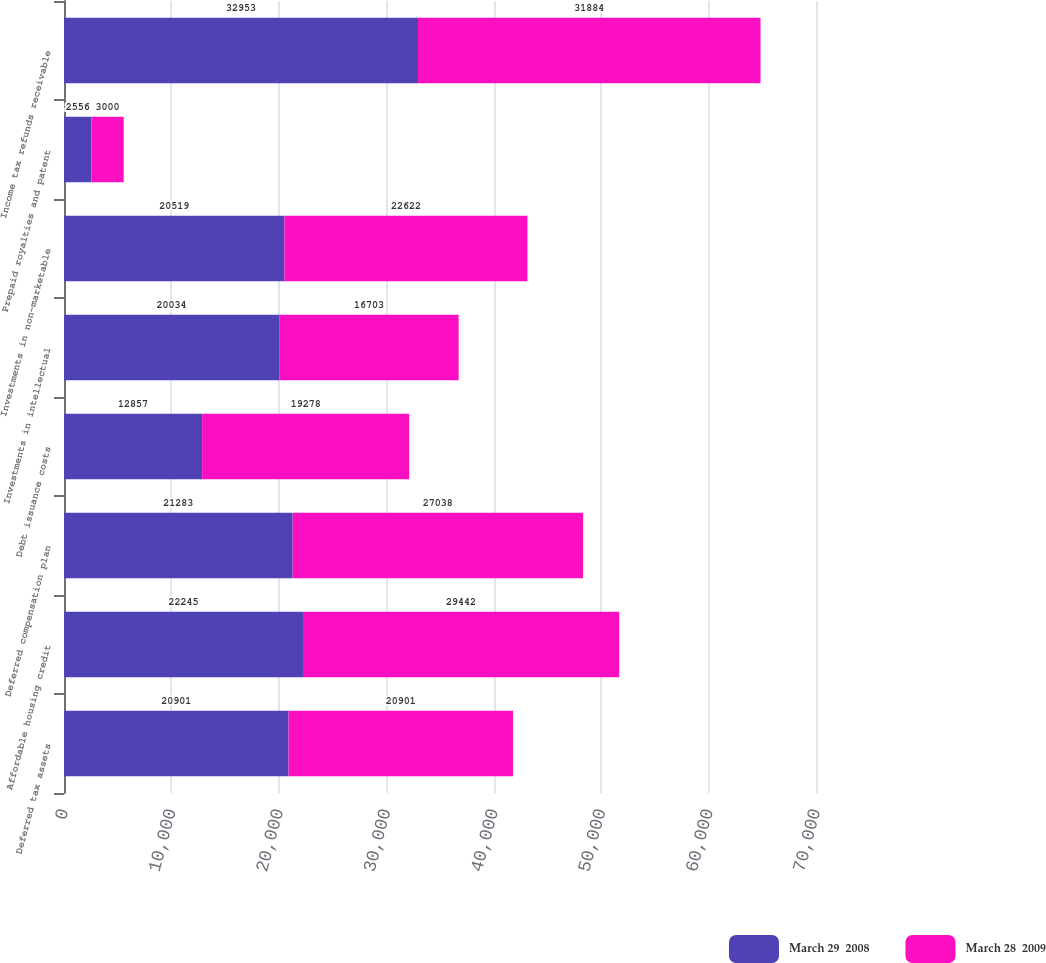Convert chart. <chart><loc_0><loc_0><loc_500><loc_500><stacked_bar_chart><ecel><fcel>Deferred tax assets<fcel>Affordable housing credit<fcel>Deferred compensation plan<fcel>Debt issuance costs<fcel>Investments in intellectual<fcel>Investments in non-marketable<fcel>Prepaid royalties and patent<fcel>Income tax refunds receivable<nl><fcel>March 29  2008<fcel>20901<fcel>22245<fcel>21283<fcel>12857<fcel>20034<fcel>20519<fcel>2556<fcel>32953<nl><fcel>March 28  2009<fcel>20901<fcel>29442<fcel>27038<fcel>19278<fcel>16703<fcel>22622<fcel>3000<fcel>31884<nl></chart> 